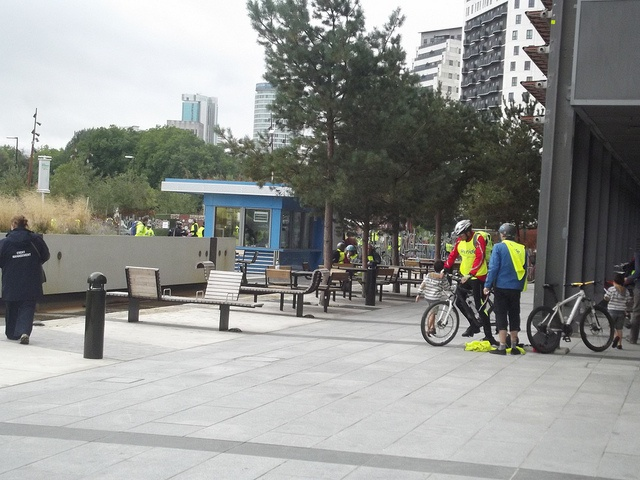Describe the objects in this image and their specific colors. I can see people in lightgray, black, gray, and darkgray tones, bicycle in lightgray, black, gray, and darkgray tones, people in lightgray, black, blue, gray, and navy tones, people in lightgray, black, yellow, gray, and brown tones, and bench in lightgray, darkgray, gray, and black tones in this image. 